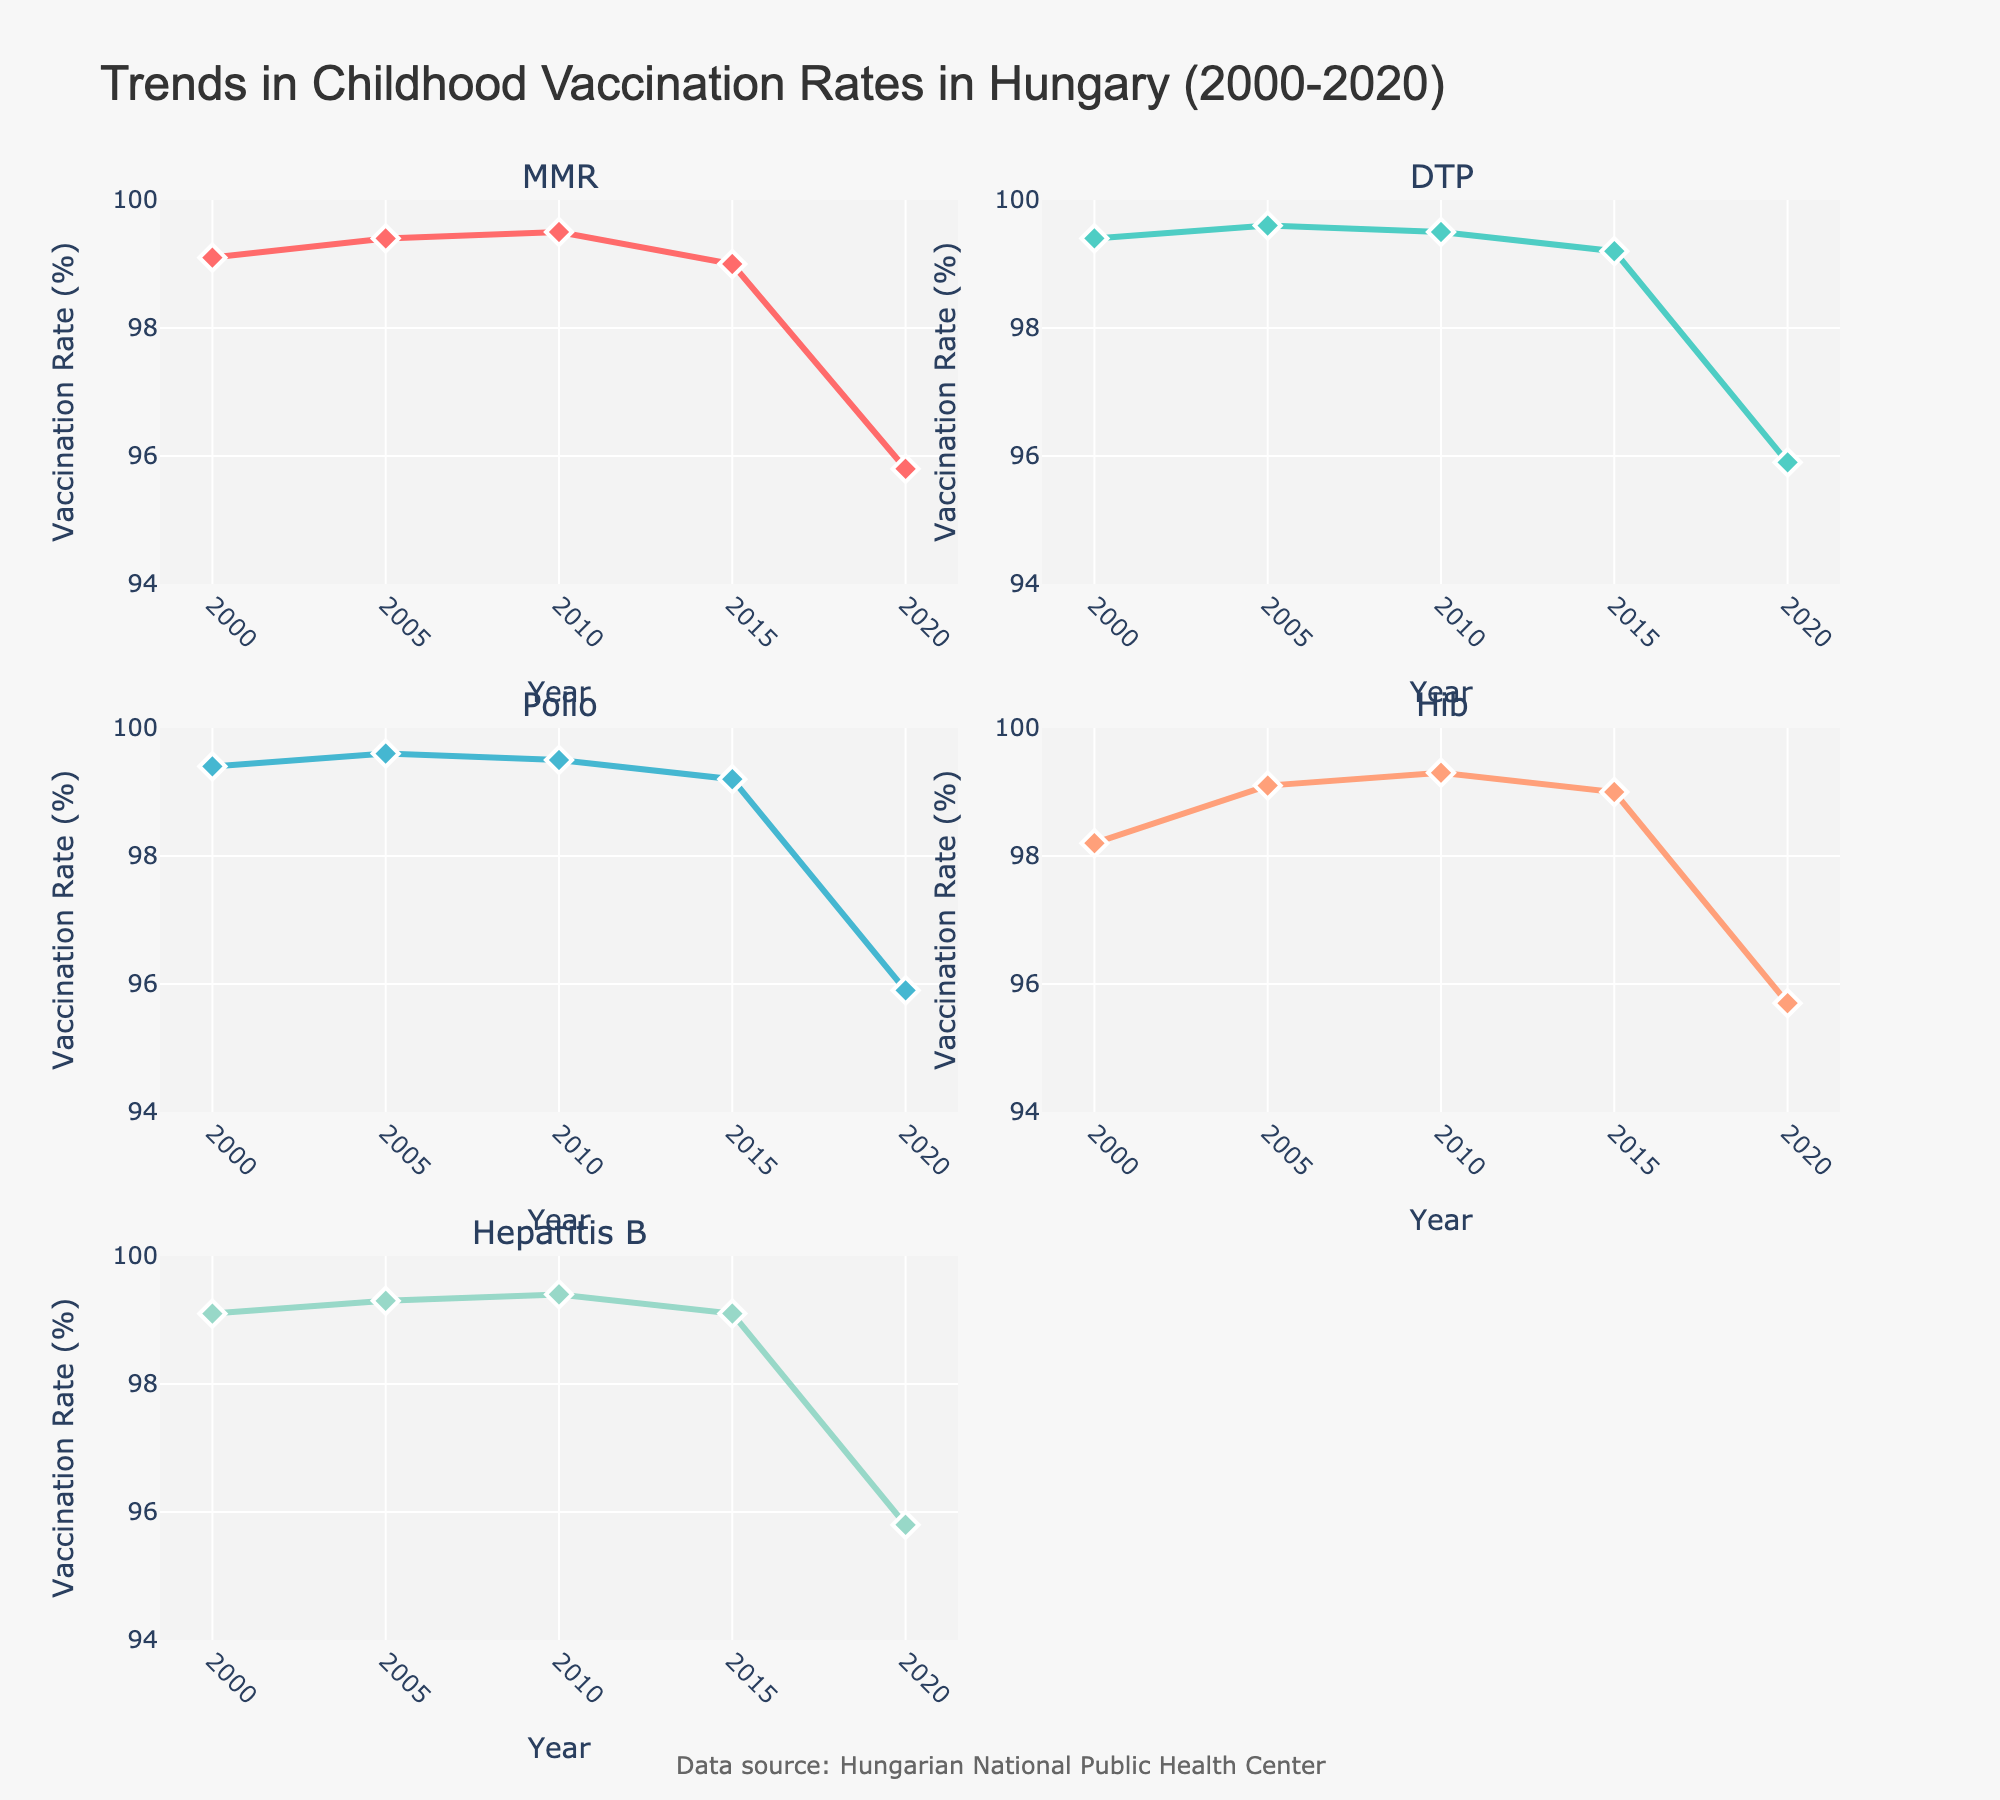Which vaccine had the highest vaccination rate in 2010? Look at the lines in the subplot for the year 2010 and check the y-axis values for each vaccine. The "MMR", "DTP", and "Polio" rates are all at 99.5%.
Answer: MMR, DTP, Polio How did the vaccinations rates for MMR and Hib change between 2015 and 2020? Compare the y-values of the MMR and Hib lines for 2015 and 2020. Both MMR and Hib show a noticeable drop from 2015 to 2020. MMR fell from 99.0% to 95.8%, and Hib fell from 99.0% to 95.7%.
Answer: Both decreased What is the overall trend in vaccination rates in Hungary from 2000 to 2020? Look at the trend lines for all vaccines from 2000 to 2020. All vaccines show a general decline in vaccination rates over the years.
Answer: Decreasing For how many years were the vaccination rates for all vaccines 99% or higher? Check each subplot to see how many data points for each vaccine are at or above 99% over the 5 given years. All vaccines were at or above 99% from 2000 to 2015.
Answer: 4 years Which vaccine saw the largest percentage drop in vaccination rate between 2015 and 2020? Subtract the 2015 rate from the 2020 rate for each vaccine. MMR and Hepatitis B both dropped from 99.0% and 99.1% respectively to 95.8%.
Answer: Hepatitis B Did any vaccine have a consistent vaccination rate over the 20 years? Check the lines in all subplots to see if any lines remain constant. None of the lines are completely flat, indicating variability over the years.
Answer: No In which year did the vaccine rates first show a noticeable decline? Look for the first significant drop in the trend lines across all subplots. It is clear that 2020 showed a marked decline across all vaccines.
Answer: 2020 What was the vaccination rate for DTP in 2005? Find the DTP line in the subplot and identify the corresponding y-axis value for the year 2005. The rate is 99.6%.
Answer: 99.6% Is there any year where the vaccination rates for all vaccines were at their highest? Check all the subplots and see if there's a common year where all vaccines reached their peak. In 2010, "MMR", "DTP", and "Polio" all recorded 99.5%, which seems to be the peak for most vaccines.
Answer: 2010 Which pair of vaccines had the most similar trend lines from 2000 to 2020? Observe the trend lines of the vaccines and compare their shapes and slopes. MMR and Hepatitis B appear to closely follow each other from 2000 to 2020.
Answer: MMR and Hepatitis B 